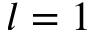Convert formula to latex. <formula><loc_0><loc_0><loc_500><loc_500>l = 1</formula> 